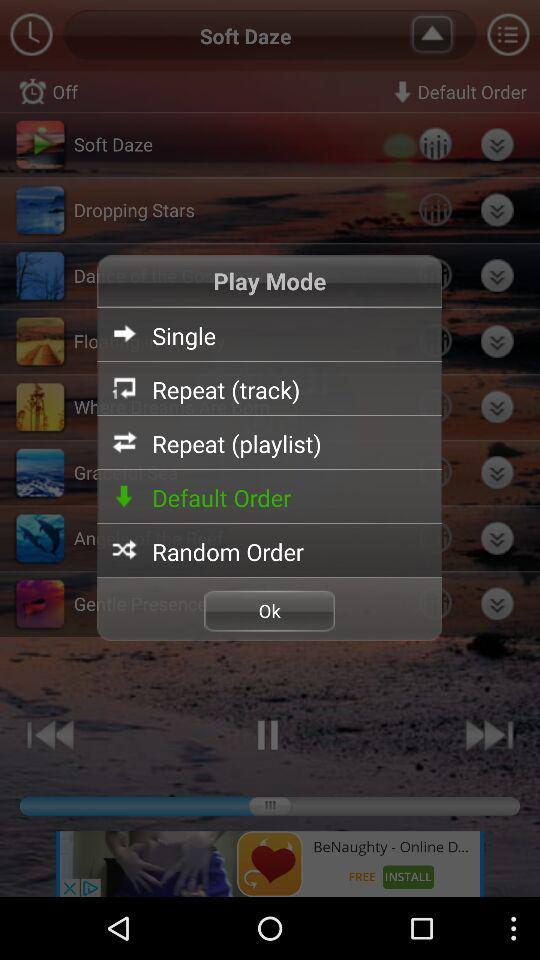What is the volume percentage of the "Rowing"? The volume percentage of the "Rowing" is 30. 